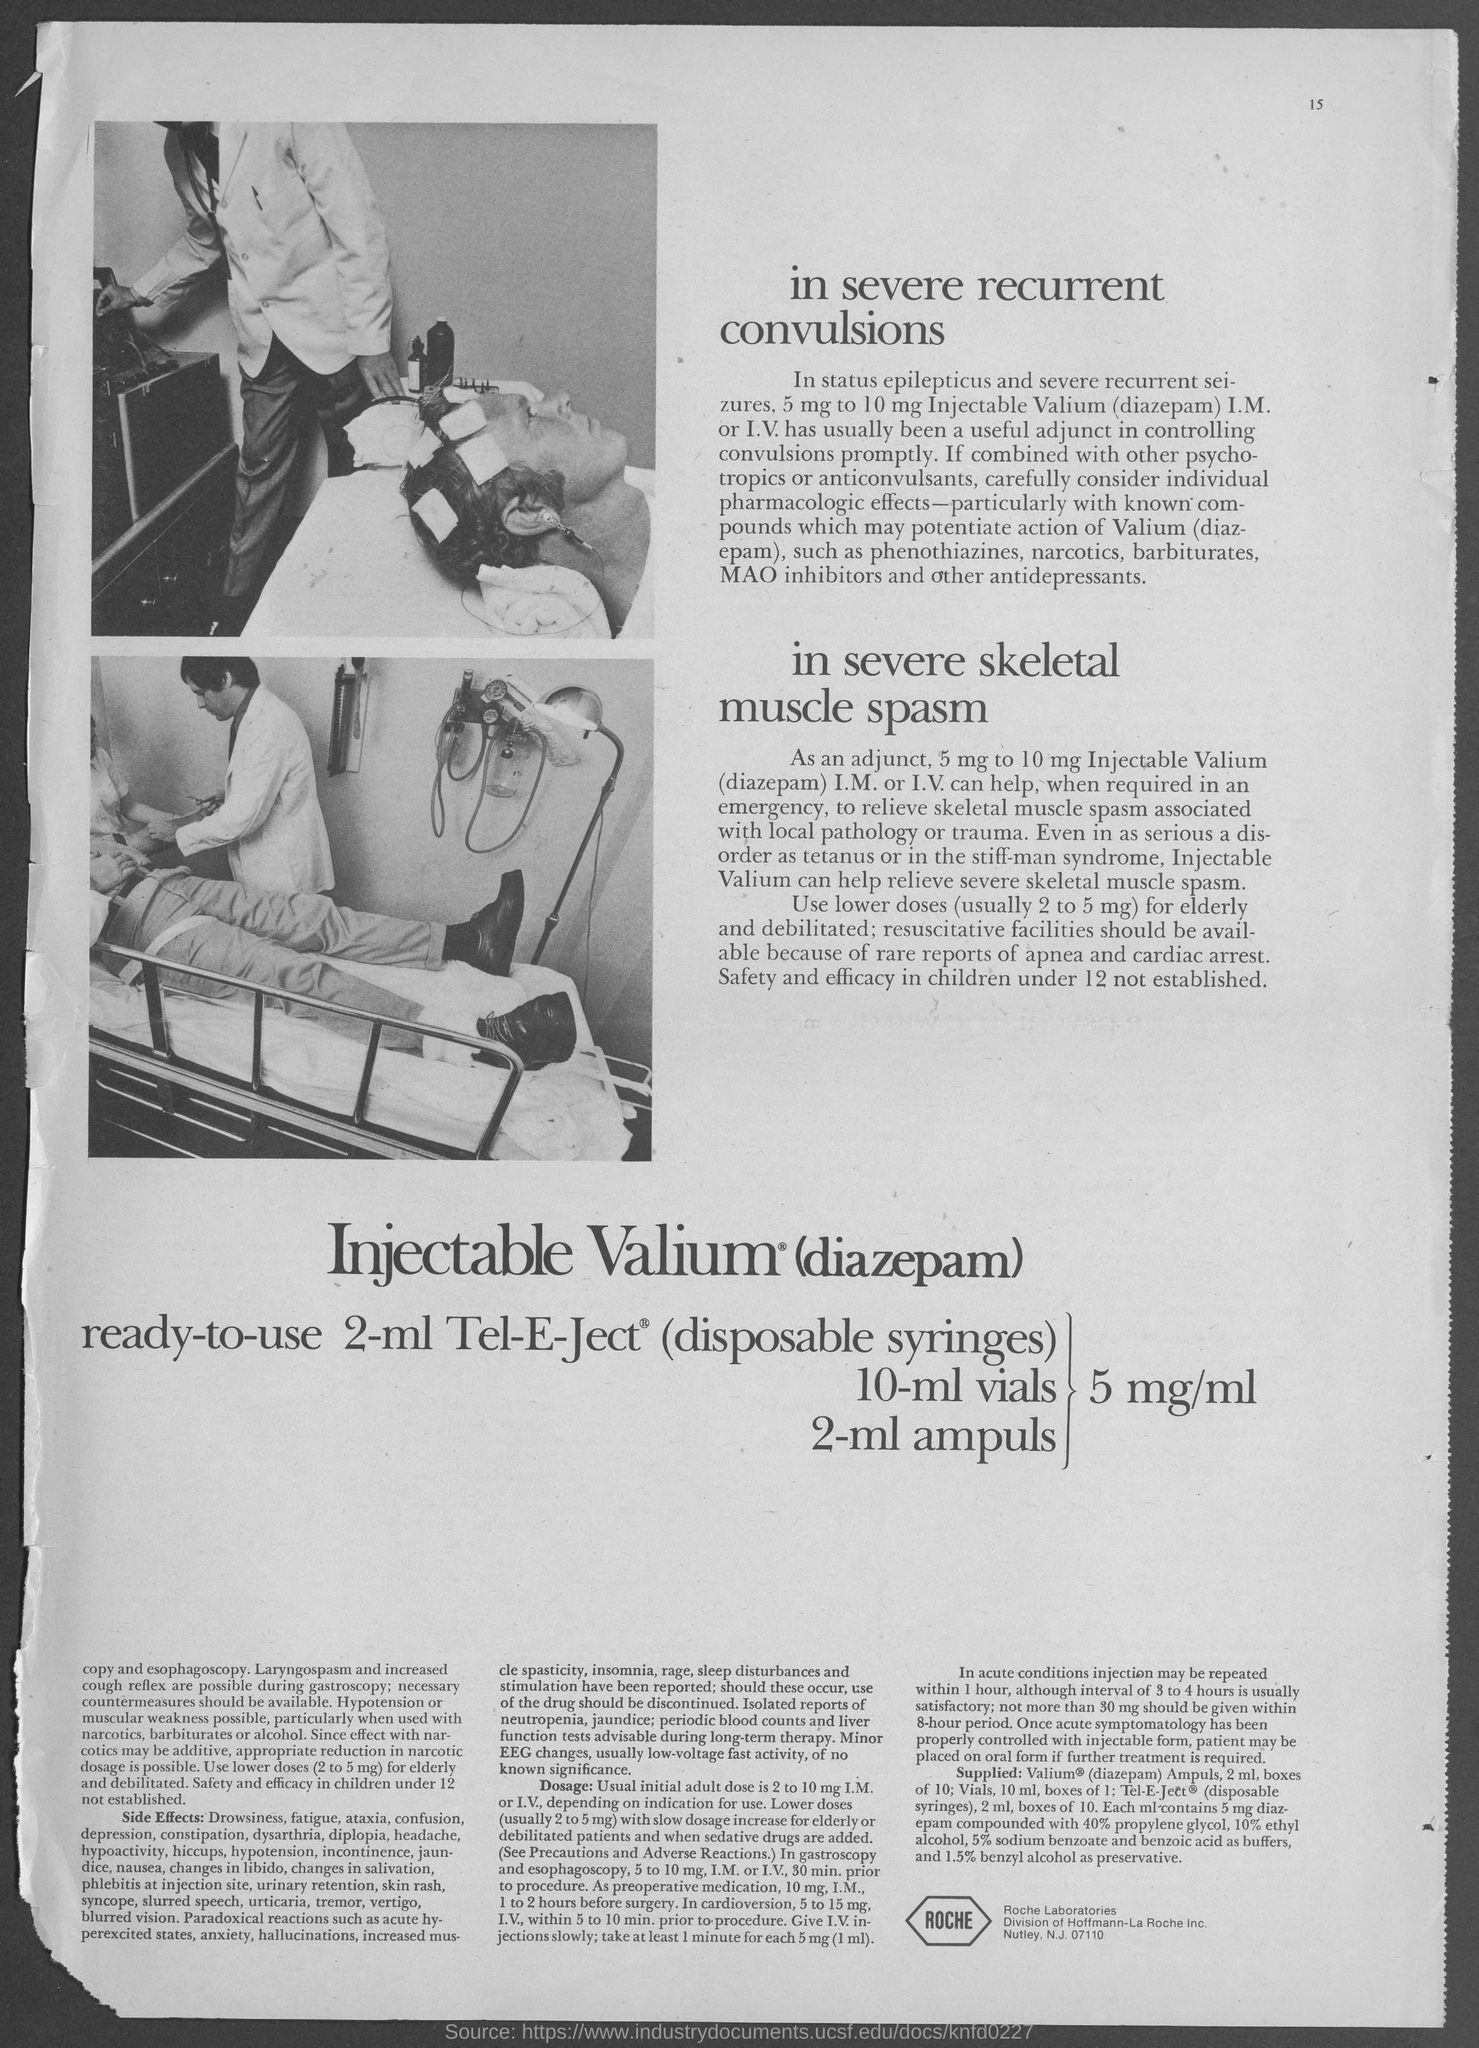Identify some key points in this picture. Roche Laboratories is located in Nutley, a city in the United States. 